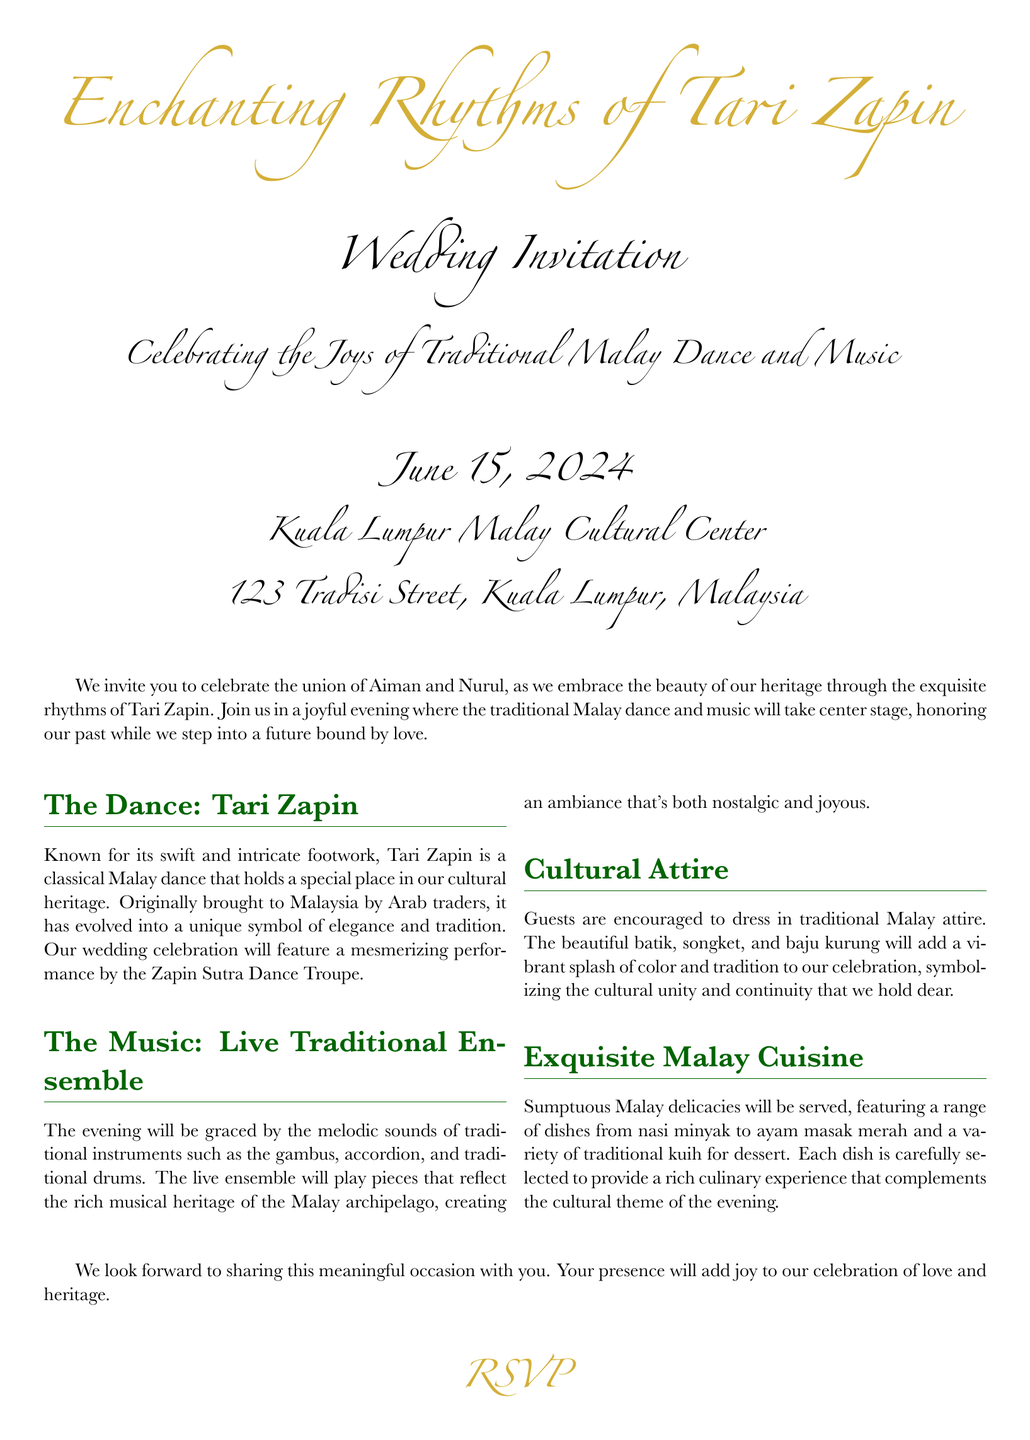What is the title of the event? The title of the event is prominently displayed at the top of the invitation.
Answer: Enchanting Rhythms of Tari Zapin When is the wedding date? The date of the wedding is mentioned in a larger font to make it stand out.
Answer: June 15, 2024 Where is the venue located? The venue location is specified in the address portion of the invitation.
Answer: Kuala Lumpur Malay Cultural Center Who are the couple getting married? The couple's names are mentioned in the invitation text prior to the event details.
Answer: Aiman and Nurul What type of dance will be performed? The type of dance is specified in the section focused on the dance details.
Answer: Tari Zapin What type of cuisine will be served at the wedding? The type of cuisine is described in the section dedicated to food, highlighting cultural aspects.
Answer: Malay delicacies What should guests wear to the wedding? The invitation encourages guests to wear specific attire that fits the cultural theme.
Answer: Traditional Malay attire What is the name of the dance troupe performing? The dance troupe's name is mentioned in the section describing the dance performance.
Answer: Zapin Sutra Dance Troupe How can attendees RSVP? The RSVP information is provided at the end of the invitation for clarity.
Answer: Lina Abdul 